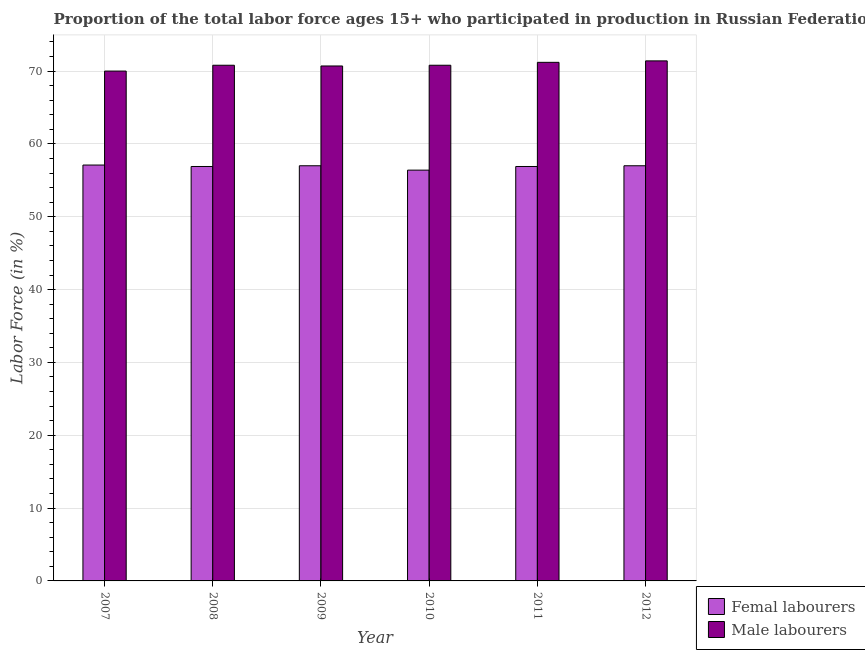How many different coloured bars are there?
Provide a short and direct response. 2. Are the number of bars on each tick of the X-axis equal?
Provide a short and direct response. Yes. How many bars are there on the 1st tick from the left?
Give a very brief answer. 2. In how many cases, is the number of bars for a given year not equal to the number of legend labels?
Provide a succinct answer. 0. What is the percentage of female labor force in 2011?
Ensure brevity in your answer.  56.9. Across all years, what is the maximum percentage of female labor force?
Your answer should be very brief. 57.1. Across all years, what is the minimum percentage of female labor force?
Your answer should be very brief. 56.4. In which year was the percentage of female labor force maximum?
Ensure brevity in your answer.  2007. What is the total percentage of female labor force in the graph?
Give a very brief answer. 341.3. What is the difference between the percentage of male labour force in 2007 and that in 2011?
Your answer should be compact. -1.2. What is the difference between the percentage of male labour force in 2009 and the percentage of female labor force in 2007?
Ensure brevity in your answer.  0.7. What is the average percentage of male labour force per year?
Offer a terse response. 70.82. In the year 2010, what is the difference between the percentage of female labor force and percentage of male labour force?
Your response must be concise. 0. In how many years, is the percentage of female labor force greater than 62 %?
Provide a succinct answer. 0. What is the ratio of the percentage of female labor force in 2007 to that in 2011?
Your answer should be very brief. 1. Is the percentage of female labor force in 2007 less than that in 2008?
Make the answer very short. No. Is the difference between the percentage of male labour force in 2007 and 2010 greater than the difference between the percentage of female labor force in 2007 and 2010?
Offer a very short reply. No. What is the difference between the highest and the second highest percentage of male labour force?
Ensure brevity in your answer.  0.2. What is the difference between the highest and the lowest percentage of female labor force?
Provide a short and direct response. 0.7. What does the 1st bar from the left in 2008 represents?
Your answer should be compact. Femal labourers. What does the 2nd bar from the right in 2008 represents?
Offer a very short reply. Femal labourers. How many bars are there?
Give a very brief answer. 12. Are all the bars in the graph horizontal?
Your response must be concise. No. How many years are there in the graph?
Your response must be concise. 6. What is the difference between two consecutive major ticks on the Y-axis?
Your response must be concise. 10. Does the graph contain grids?
Give a very brief answer. Yes. How many legend labels are there?
Provide a succinct answer. 2. How are the legend labels stacked?
Give a very brief answer. Vertical. What is the title of the graph?
Your answer should be compact. Proportion of the total labor force ages 15+ who participated in production in Russian Federation. Does "Research and Development" appear as one of the legend labels in the graph?
Your response must be concise. No. What is the label or title of the X-axis?
Offer a very short reply. Year. What is the Labor Force (in %) in Femal labourers in 2007?
Your response must be concise. 57.1. What is the Labor Force (in %) of Femal labourers in 2008?
Keep it short and to the point. 56.9. What is the Labor Force (in %) in Male labourers in 2008?
Provide a succinct answer. 70.8. What is the Labor Force (in %) of Femal labourers in 2009?
Your answer should be compact. 57. What is the Labor Force (in %) of Male labourers in 2009?
Your answer should be very brief. 70.7. What is the Labor Force (in %) of Femal labourers in 2010?
Keep it short and to the point. 56.4. What is the Labor Force (in %) in Male labourers in 2010?
Offer a very short reply. 70.8. What is the Labor Force (in %) of Femal labourers in 2011?
Your answer should be compact. 56.9. What is the Labor Force (in %) of Male labourers in 2011?
Make the answer very short. 71.2. What is the Labor Force (in %) of Femal labourers in 2012?
Give a very brief answer. 57. What is the Labor Force (in %) in Male labourers in 2012?
Provide a succinct answer. 71.4. Across all years, what is the maximum Labor Force (in %) in Femal labourers?
Offer a terse response. 57.1. Across all years, what is the maximum Labor Force (in %) in Male labourers?
Offer a very short reply. 71.4. Across all years, what is the minimum Labor Force (in %) in Femal labourers?
Offer a terse response. 56.4. What is the total Labor Force (in %) of Femal labourers in the graph?
Your response must be concise. 341.3. What is the total Labor Force (in %) in Male labourers in the graph?
Your answer should be compact. 424.9. What is the difference between the Labor Force (in %) of Male labourers in 2007 and that in 2008?
Your answer should be compact. -0.8. What is the difference between the Labor Force (in %) of Femal labourers in 2007 and that in 2009?
Offer a terse response. 0.1. What is the difference between the Labor Force (in %) of Male labourers in 2007 and that in 2009?
Provide a succinct answer. -0.7. What is the difference between the Labor Force (in %) of Male labourers in 2007 and that in 2010?
Provide a succinct answer. -0.8. What is the difference between the Labor Force (in %) in Femal labourers in 2007 and that in 2011?
Your response must be concise. 0.2. What is the difference between the Labor Force (in %) in Male labourers in 2007 and that in 2012?
Your response must be concise. -1.4. What is the difference between the Labor Force (in %) in Femal labourers in 2008 and that in 2010?
Your response must be concise. 0.5. What is the difference between the Labor Force (in %) in Male labourers in 2008 and that in 2011?
Make the answer very short. -0.4. What is the difference between the Labor Force (in %) of Femal labourers in 2008 and that in 2012?
Your response must be concise. -0.1. What is the difference between the Labor Force (in %) of Male labourers in 2008 and that in 2012?
Your response must be concise. -0.6. What is the difference between the Labor Force (in %) of Male labourers in 2009 and that in 2011?
Your answer should be very brief. -0.5. What is the difference between the Labor Force (in %) in Male labourers in 2010 and that in 2011?
Your response must be concise. -0.4. What is the difference between the Labor Force (in %) in Femal labourers in 2010 and that in 2012?
Ensure brevity in your answer.  -0.6. What is the difference between the Labor Force (in %) in Male labourers in 2010 and that in 2012?
Give a very brief answer. -0.6. What is the difference between the Labor Force (in %) in Femal labourers in 2011 and that in 2012?
Your answer should be compact. -0.1. What is the difference between the Labor Force (in %) in Male labourers in 2011 and that in 2012?
Offer a terse response. -0.2. What is the difference between the Labor Force (in %) of Femal labourers in 2007 and the Labor Force (in %) of Male labourers in 2008?
Make the answer very short. -13.7. What is the difference between the Labor Force (in %) in Femal labourers in 2007 and the Labor Force (in %) in Male labourers in 2009?
Your answer should be compact. -13.6. What is the difference between the Labor Force (in %) in Femal labourers in 2007 and the Labor Force (in %) in Male labourers in 2010?
Provide a short and direct response. -13.7. What is the difference between the Labor Force (in %) of Femal labourers in 2007 and the Labor Force (in %) of Male labourers in 2011?
Offer a terse response. -14.1. What is the difference between the Labor Force (in %) in Femal labourers in 2007 and the Labor Force (in %) in Male labourers in 2012?
Provide a short and direct response. -14.3. What is the difference between the Labor Force (in %) of Femal labourers in 2008 and the Labor Force (in %) of Male labourers in 2009?
Make the answer very short. -13.8. What is the difference between the Labor Force (in %) of Femal labourers in 2008 and the Labor Force (in %) of Male labourers in 2011?
Give a very brief answer. -14.3. What is the difference between the Labor Force (in %) in Femal labourers in 2009 and the Labor Force (in %) in Male labourers in 2010?
Ensure brevity in your answer.  -13.8. What is the difference between the Labor Force (in %) in Femal labourers in 2009 and the Labor Force (in %) in Male labourers in 2011?
Your answer should be compact. -14.2. What is the difference between the Labor Force (in %) in Femal labourers in 2009 and the Labor Force (in %) in Male labourers in 2012?
Offer a very short reply. -14.4. What is the difference between the Labor Force (in %) in Femal labourers in 2010 and the Labor Force (in %) in Male labourers in 2011?
Your answer should be compact. -14.8. What is the average Labor Force (in %) in Femal labourers per year?
Offer a very short reply. 56.88. What is the average Labor Force (in %) in Male labourers per year?
Give a very brief answer. 70.82. In the year 2007, what is the difference between the Labor Force (in %) of Femal labourers and Labor Force (in %) of Male labourers?
Your answer should be very brief. -12.9. In the year 2008, what is the difference between the Labor Force (in %) in Femal labourers and Labor Force (in %) in Male labourers?
Provide a short and direct response. -13.9. In the year 2009, what is the difference between the Labor Force (in %) in Femal labourers and Labor Force (in %) in Male labourers?
Ensure brevity in your answer.  -13.7. In the year 2010, what is the difference between the Labor Force (in %) of Femal labourers and Labor Force (in %) of Male labourers?
Give a very brief answer. -14.4. In the year 2011, what is the difference between the Labor Force (in %) of Femal labourers and Labor Force (in %) of Male labourers?
Keep it short and to the point. -14.3. In the year 2012, what is the difference between the Labor Force (in %) of Femal labourers and Labor Force (in %) of Male labourers?
Ensure brevity in your answer.  -14.4. What is the ratio of the Labor Force (in %) of Male labourers in 2007 to that in 2008?
Offer a very short reply. 0.99. What is the ratio of the Labor Force (in %) in Femal labourers in 2007 to that in 2010?
Provide a short and direct response. 1.01. What is the ratio of the Labor Force (in %) in Male labourers in 2007 to that in 2010?
Give a very brief answer. 0.99. What is the ratio of the Labor Force (in %) in Male labourers in 2007 to that in 2011?
Your answer should be very brief. 0.98. What is the ratio of the Labor Force (in %) of Male labourers in 2007 to that in 2012?
Keep it short and to the point. 0.98. What is the ratio of the Labor Force (in %) of Male labourers in 2008 to that in 2009?
Ensure brevity in your answer.  1. What is the ratio of the Labor Force (in %) in Femal labourers in 2008 to that in 2010?
Make the answer very short. 1.01. What is the ratio of the Labor Force (in %) in Femal labourers in 2008 to that in 2011?
Your answer should be very brief. 1. What is the ratio of the Labor Force (in %) of Male labourers in 2008 to that in 2011?
Your answer should be very brief. 0.99. What is the ratio of the Labor Force (in %) in Femal labourers in 2008 to that in 2012?
Offer a terse response. 1. What is the ratio of the Labor Force (in %) of Femal labourers in 2009 to that in 2010?
Offer a very short reply. 1.01. What is the ratio of the Labor Force (in %) of Male labourers in 2009 to that in 2010?
Offer a very short reply. 1. What is the ratio of the Labor Force (in %) in Femal labourers in 2009 to that in 2012?
Keep it short and to the point. 1. What is the ratio of the Labor Force (in %) in Male labourers in 2009 to that in 2012?
Your response must be concise. 0.99. What is the ratio of the Labor Force (in %) of Femal labourers in 2010 to that in 2011?
Offer a very short reply. 0.99. What is the ratio of the Labor Force (in %) of Male labourers in 2010 to that in 2011?
Offer a very short reply. 0.99. What is the ratio of the Labor Force (in %) in Femal labourers in 2010 to that in 2012?
Give a very brief answer. 0.99. What is the ratio of the Labor Force (in %) in Male labourers in 2010 to that in 2012?
Provide a succinct answer. 0.99. What is the ratio of the Labor Force (in %) in Femal labourers in 2011 to that in 2012?
Provide a short and direct response. 1. What is the difference between the highest and the second highest Labor Force (in %) in Femal labourers?
Offer a very short reply. 0.1. What is the difference between the highest and the second highest Labor Force (in %) in Male labourers?
Offer a very short reply. 0.2. 